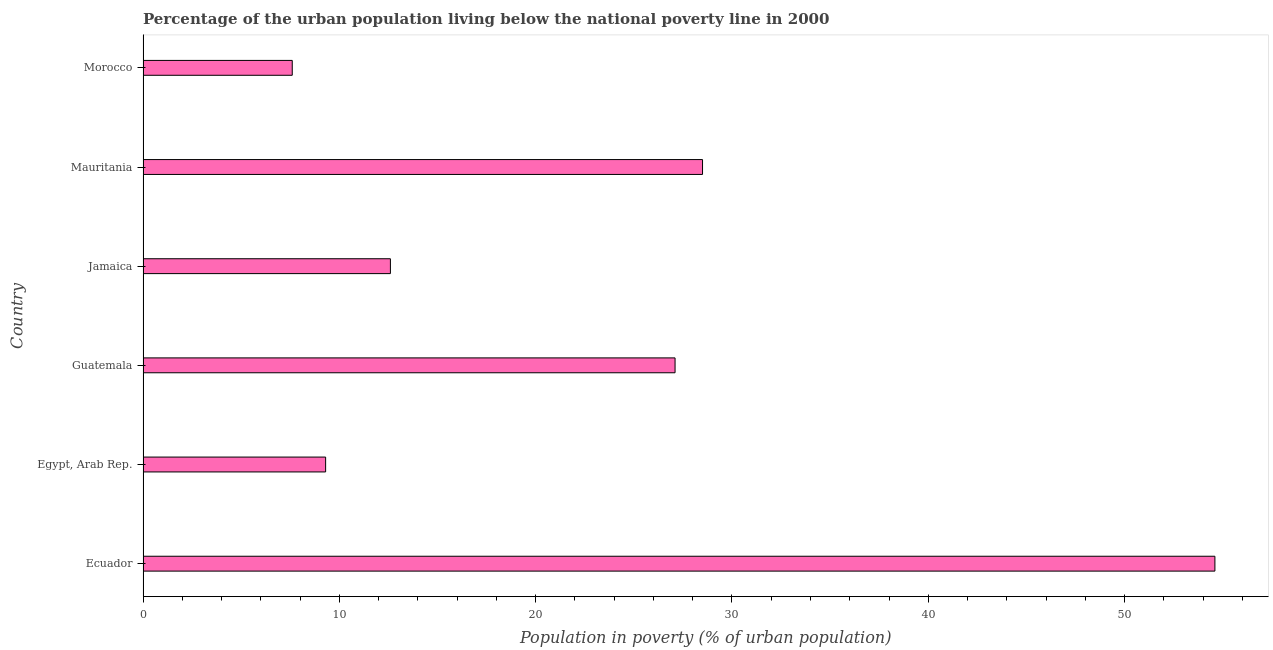Does the graph contain any zero values?
Your answer should be very brief. No. Does the graph contain grids?
Ensure brevity in your answer.  No. What is the title of the graph?
Give a very brief answer. Percentage of the urban population living below the national poverty line in 2000. What is the label or title of the X-axis?
Ensure brevity in your answer.  Population in poverty (% of urban population). What is the percentage of urban population living below poverty line in Guatemala?
Provide a succinct answer. 27.1. Across all countries, what is the maximum percentage of urban population living below poverty line?
Keep it short and to the point. 54.6. In which country was the percentage of urban population living below poverty line maximum?
Keep it short and to the point. Ecuador. In which country was the percentage of urban population living below poverty line minimum?
Ensure brevity in your answer.  Morocco. What is the sum of the percentage of urban population living below poverty line?
Give a very brief answer. 139.7. What is the difference between the percentage of urban population living below poverty line in Ecuador and Mauritania?
Keep it short and to the point. 26.1. What is the average percentage of urban population living below poverty line per country?
Keep it short and to the point. 23.28. What is the median percentage of urban population living below poverty line?
Provide a succinct answer. 19.85. What is the ratio of the percentage of urban population living below poverty line in Egypt, Arab Rep. to that in Mauritania?
Ensure brevity in your answer.  0.33. Is the difference between the percentage of urban population living below poverty line in Egypt, Arab Rep. and Jamaica greater than the difference between any two countries?
Your answer should be compact. No. What is the difference between the highest and the second highest percentage of urban population living below poverty line?
Offer a very short reply. 26.1. Is the sum of the percentage of urban population living below poverty line in Ecuador and Guatemala greater than the maximum percentage of urban population living below poverty line across all countries?
Your response must be concise. Yes. What is the difference between the highest and the lowest percentage of urban population living below poverty line?
Ensure brevity in your answer.  47. How many countries are there in the graph?
Offer a very short reply. 6. What is the difference between two consecutive major ticks on the X-axis?
Your answer should be very brief. 10. What is the Population in poverty (% of urban population) in Ecuador?
Give a very brief answer. 54.6. What is the Population in poverty (% of urban population) in Guatemala?
Offer a terse response. 27.1. What is the Population in poverty (% of urban population) of Mauritania?
Offer a terse response. 28.5. What is the Population in poverty (% of urban population) of Morocco?
Make the answer very short. 7.6. What is the difference between the Population in poverty (% of urban population) in Ecuador and Egypt, Arab Rep.?
Your answer should be compact. 45.3. What is the difference between the Population in poverty (% of urban population) in Ecuador and Guatemala?
Offer a very short reply. 27.5. What is the difference between the Population in poverty (% of urban population) in Ecuador and Mauritania?
Keep it short and to the point. 26.1. What is the difference between the Population in poverty (% of urban population) in Egypt, Arab Rep. and Guatemala?
Your answer should be very brief. -17.8. What is the difference between the Population in poverty (% of urban population) in Egypt, Arab Rep. and Jamaica?
Your answer should be compact. -3.3. What is the difference between the Population in poverty (% of urban population) in Egypt, Arab Rep. and Mauritania?
Your answer should be compact. -19.2. What is the difference between the Population in poverty (% of urban population) in Guatemala and Jamaica?
Give a very brief answer. 14.5. What is the difference between the Population in poverty (% of urban population) in Guatemala and Mauritania?
Your answer should be compact. -1.4. What is the difference between the Population in poverty (% of urban population) in Guatemala and Morocco?
Offer a terse response. 19.5. What is the difference between the Population in poverty (% of urban population) in Jamaica and Mauritania?
Provide a succinct answer. -15.9. What is the difference between the Population in poverty (% of urban population) in Mauritania and Morocco?
Your answer should be compact. 20.9. What is the ratio of the Population in poverty (% of urban population) in Ecuador to that in Egypt, Arab Rep.?
Your answer should be very brief. 5.87. What is the ratio of the Population in poverty (% of urban population) in Ecuador to that in Guatemala?
Keep it short and to the point. 2.02. What is the ratio of the Population in poverty (% of urban population) in Ecuador to that in Jamaica?
Provide a short and direct response. 4.33. What is the ratio of the Population in poverty (% of urban population) in Ecuador to that in Mauritania?
Give a very brief answer. 1.92. What is the ratio of the Population in poverty (% of urban population) in Ecuador to that in Morocco?
Keep it short and to the point. 7.18. What is the ratio of the Population in poverty (% of urban population) in Egypt, Arab Rep. to that in Guatemala?
Keep it short and to the point. 0.34. What is the ratio of the Population in poverty (% of urban population) in Egypt, Arab Rep. to that in Jamaica?
Keep it short and to the point. 0.74. What is the ratio of the Population in poverty (% of urban population) in Egypt, Arab Rep. to that in Mauritania?
Your response must be concise. 0.33. What is the ratio of the Population in poverty (% of urban population) in Egypt, Arab Rep. to that in Morocco?
Offer a terse response. 1.22. What is the ratio of the Population in poverty (% of urban population) in Guatemala to that in Jamaica?
Your answer should be very brief. 2.15. What is the ratio of the Population in poverty (% of urban population) in Guatemala to that in Mauritania?
Offer a very short reply. 0.95. What is the ratio of the Population in poverty (% of urban population) in Guatemala to that in Morocco?
Offer a very short reply. 3.57. What is the ratio of the Population in poverty (% of urban population) in Jamaica to that in Mauritania?
Give a very brief answer. 0.44. What is the ratio of the Population in poverty (% of urban population) in Jamaica to that in Morocco?
Provide a short and direct response. 1.66. What is the ratio of the Population in poverty (% of urban population) in Mauritania to that in Morocco?
Your response must be concise. 3.75. 